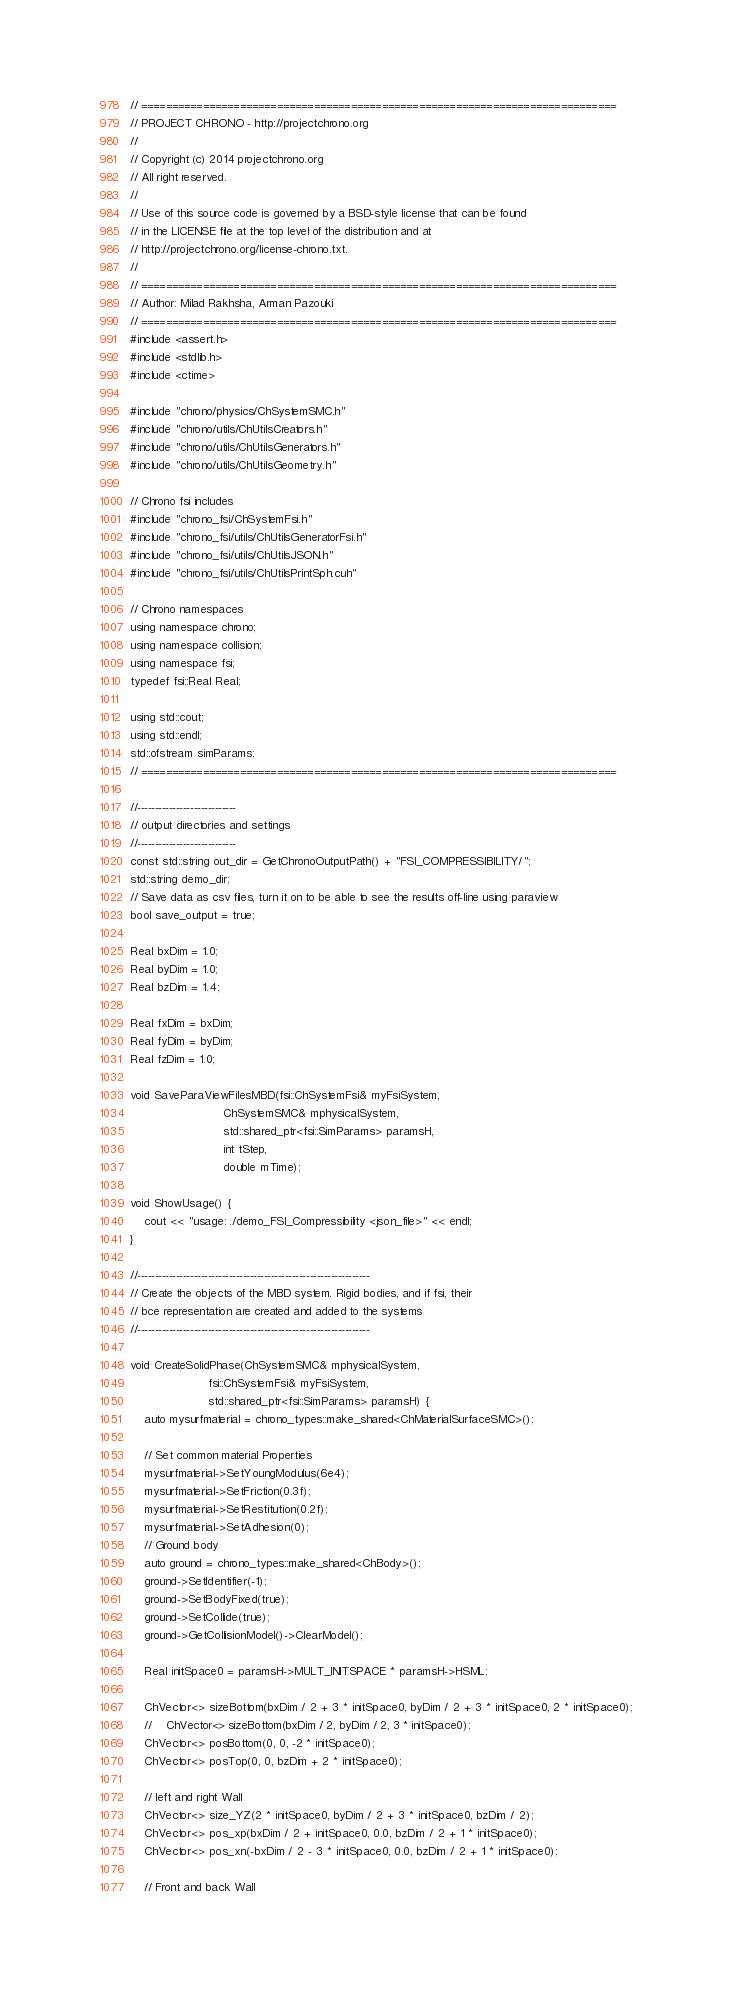Convert code to text. <code><loc_0><loc_0><loc_500><loc_500><_C++_>// =============================================================================
// PROJECT CHRONO - http://projectchrono.org
//
// Copyright (c) 2014 projectchrono.org
// All right reserved.
//
// Use of this source code is governed by a BSD-style license that can be found
// in the LICENSE file at the top level of the distribution and at
// http://projectchrono.org/license-chrono.txt.
//
// =============================================================================
// Author: Milad Rakhsha, Arman Pazouki
// =============================================================================
#include <assert.h>
#include <stdlib.h>
#include <ctime>

#include "chrono/physics/ChSystemSMC.h"
#include "chrono/utils/ChUtilsCreators.h"
#include "chrono/utils/ChUtilsGenerators.h"
#include "chrono/utils/ChUtilsGeometry.h"

// Chrono fsi includes
#include "chrono_fsi/ChSystemFsi.h"
#include "chrono_fsi/utils/ChUtilsGeneratorFsi.h"
#include "chrono_fsi/utils/ChUtilsJSON.h"
#include "chrono_fsi/utils/ChUtilsPrintSph.cuh"

// Chrono namespaces
using namespace chrono;
using namespace collision;
using namespace fsi;
typedef fsi::Real Real;

using std::cout;
using std::endl;
std::ofstream simParams;
// =============================================================================

//----------------------------
// output directories and settings
//----------------------------
const std::string out_dir = GetChronoOutputPath() + "FSI_COMPRESSIBILITY/";
std::string demo_dir;
// Save data as csv files, turn it on to be able to see the results off-line using paraview
bool save_output = true;

Real bxDim = 1.0;
Real byDim = 1.0;
Real bzDim = 1.4;

Real fxDim = bxDim;
Real fyDim = byDim;
Real fzDim = 1.0;

void SaveParaViewFilesMBD(fsi::ChSystemFsi& myFsiSystem,
                          ChSystemSMC& mphysicalSystem,
                          std::shared_ptr<fsi::SimParams> paramsH,
                          int tStep,
                          double mTime);

void ShowUsage() {
    cout << "usage: ./demo_FSI_Compressibility <json_file>" << endl;
}

//------------------------------------------------------------------
// Create the objects of the MBD system. Rigid bodies, and if fsi, their
// bce representation are created and added to the systems
//------------------------------------------------------------------

void CreateSolidPhase(ChSystemSMC& mphysicalSystem,
                      fsi::ChSystemFsi& myFsiSystem,
                      std::shared_ptr<fsi::SimParams> paramsH) {
    auto mysurfmaterial = chrono_types::make_shared<ChMaterialSurfaceSMC>();

    // Set common material Properties
    mysurfmaterial->SetYoungModulus(6e4);
    mysurfmaterial->SetFriction(0.3f);
    mysurfmaterial->SetRestitution(0.2f);
    mysurfmaterial->SetAdhesion(0);
    // Ground body
    auto ground = chrono_types::make_shared<ChBody>();
    ground->SetIdentifier(-1);
    ground->SetBodyFixed(true);
    ground->SetCollide(true);
    ground->GetCollisionModel()->ClearModel();

    Real initSpace0 = paramsH->MULT_INITSPACE * paramsH->HSML;

    ChVector<> sizeBottom(bxDim / 2 + 3 * initSpace0, byDim / 2 + 3 * initSpace0, 2 * initSpace0);
    //    ChVector<> sizeBottom(bxDim / 2, byDim / 2, 3 * initSpace0);
    ChVector<> posBottom(0, 0, -2 * initSpace0);
    ChVector<> posTop(0, 0, bzDim + 2 * initSpace0);

    // left and right Wall
    ChVector<> size_YZ(2 * initSpace0, byDim / 2 + 3 * initSpace0, bzDim / 2);
    ChVector<> pos_xp(bxDim / 2 + initSpace0, 0.0, bzDim / 2 + 1 * initSpace0);
    ChVector<> pos_xn(-bxDim / 2 - 3 * initSpace0, 0.0, bzDim / 2 + 1 * initSpace0);

    // Front and back Wall</code> 